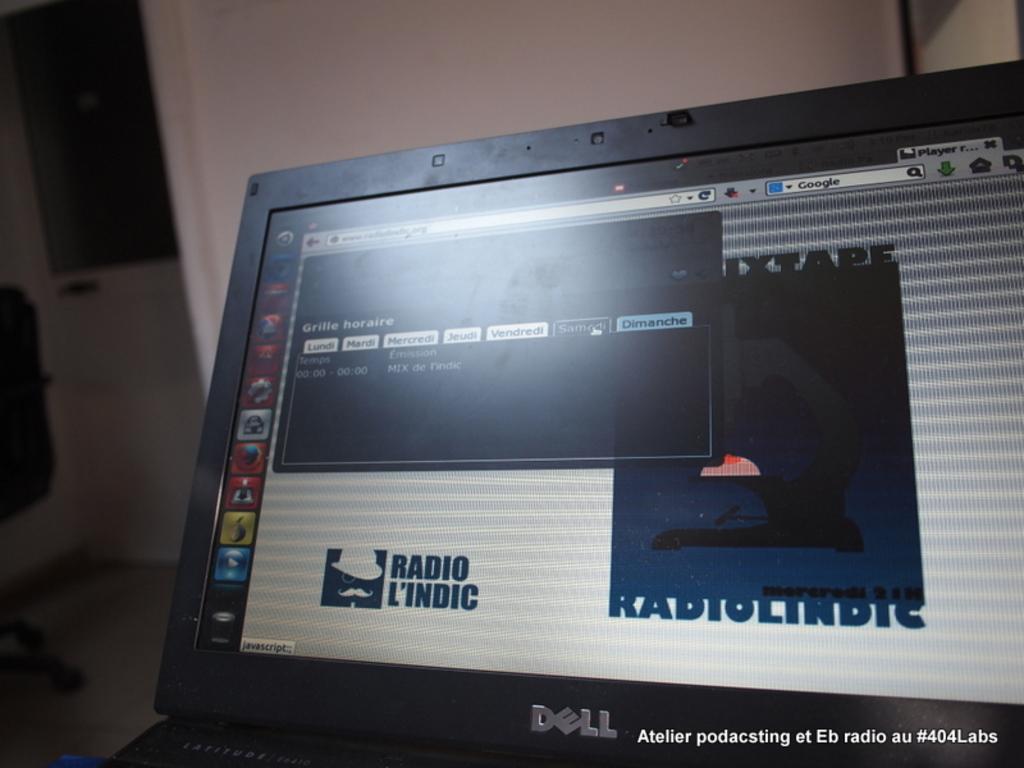What kind of computer is this?
Provide a short and direct response. Dell. What brand is the laptop?
Offer a very short reply. Dell. 